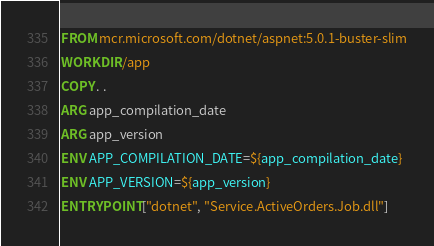Convert code to text. <code><loc_0><loc_0><loc_500><loc_500><_Dockerfile_>FROM mcr.microsoft.com/dotnet/aspnet:5.0.1-buster-slim
WORKDIR /app
COPY . .
ARG app_compilation_date
ARG app_version
ENV APP_COMPILATION_DATE=${app_compilation_date}
ENV APP_VERSION=${app_version}
ENTRYPOINT ["dotnet", "Service.ActiveOrders.Job.dll"]
</code> 